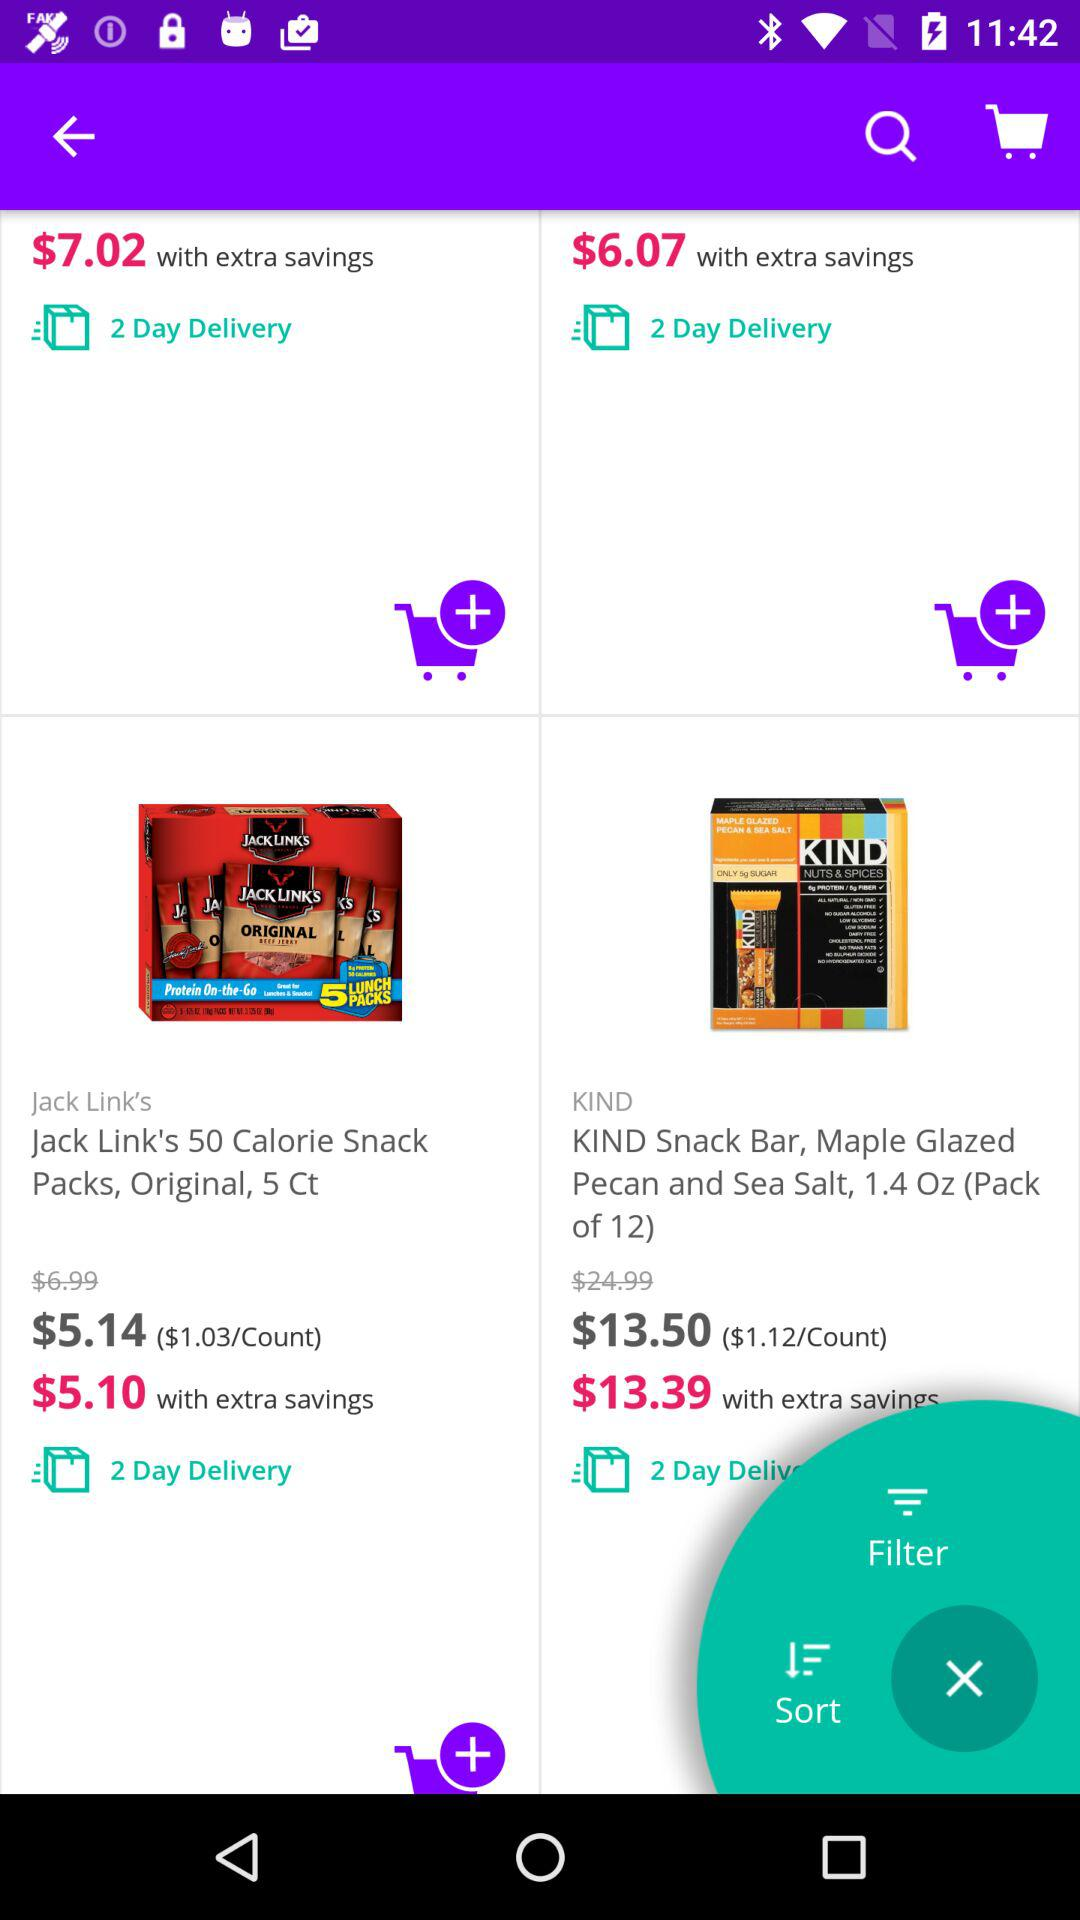What is the discounted price of the "KIND Snack Bar, Maple Glazed Pecan and Sea Salt, 1.4 Oz"? The discounted price of the "KIND Snack Bar, Maple Glazed Pecan and Sea Salt, 1.4 Oz" is $13.39. 